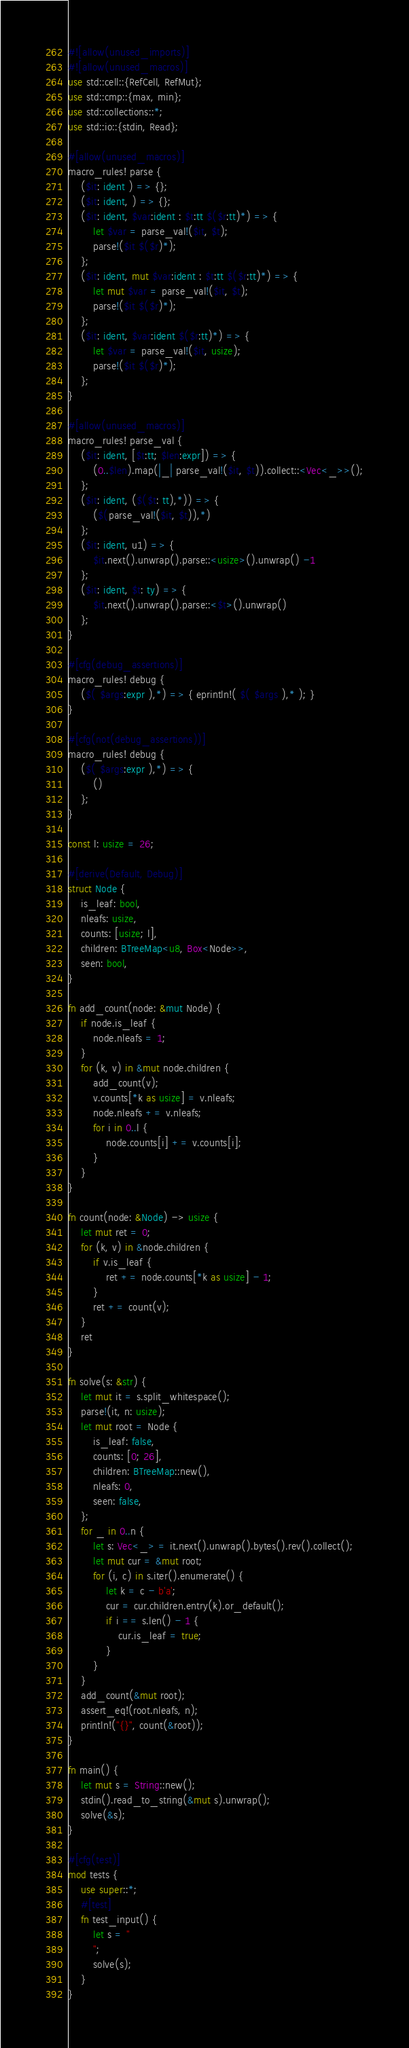<code> <loc_0><loc_0><loc_500><loc_500><_Rust_>#![allow(unused_imports)]
#![allow(unused_macros)]
use std::cell::{RefCell, RefMut};
use std::cmp::{max, min};
use std::collections::*;
use std::io::{stdin, Read};

#[allow(unused_macros)]
macro_rules! parse {
    ($it: ident ) => {};
    ($it: ident, ) => {};
    ($it: ident, $var:ident : $t:tt $($r:tt)*) => {
        let $var = parse_val!($it, $t);
        parse!($it $($r)*);
    };
    ($it: ident, mut $var:ident : $t:tt $($r:tt)*) => {
        let mut $var = parse_val!($it, $t);
        parse!($it $($r)*);
    };
    ($it: ident, $var:ident $($r:tt)*) => {
        let $var = parse_val!($it, usize);
        parse!($it $($r)*);
    };
}

#[allow(unused_macros)]
macro_rules! parse_val {
    ($it: ident, [$t:tt; $len:expr]) => {
        (0..$len).map(|_| parse_val!($it, $t)).collect::<Vec<_>>();
    };
    ($it: ident, ($($t: tt),*)) => {
        ($(parse_val!($it, $t)),*)
    };
    ($it: ident, u1) => {
        $it.next().unwrap().parse::<usize>().unwrap() -1
    };
    ($it: ident, $t: ty) => {
        $it.next().unwrap().parse::<$t>().unwrap()
    };
}

#[cfg(debug_assertions)]
macro_rules! debug {
    ($( $args:expr ),*) => { eprintln!( $( $args ),* ); }
}

#[cfg(not(debug_assertions))]
macro_rules! debug {
    ($( $args:expr ),*) => {
        ()
    };
}

const l: usize = 26;

#[derive(Default, Debug)]
struct Node {
    is_leaf: bool,
    nleafs: usize,
    counts: [usize; l],
    children: BTreeMap<u8, Box<Node>>,
    seen: bool,
}

fn add_count(node: &mut Node) {
    if node.is_leaf {
        node.nleafs = 1;
    }
    for (k, v) in &mut node.children {
        add_count(v);
        v.counts[*k as usize] = v.nleafs;
        node.nleafs += v.nleafs;
        for i in 0..l {
            node.counts[i] += v.counts[i];
        }
    }
}

fn count(node: &Node) -> usize {
    let mut ret = 0;
    for (k, v) in &node.children {
        if v.is_leaf {
            ret += node.counts[*k as usize] - 1;
        }
        ret += count(v);
    }
    ret
}

fn solve(s: &str) {
    let mut it = s.split_whitespace();
    parse!(it, n: usize);
    let mut root = Node {
        is_leaf: false,
        counts: [0; 26],
        children: BTreeMap::new(),
        nleafs: 0,
        seen: false,
    };
    for _ in 0..n {
        let s: Vec<_> = it.next().unwrap().bytes().rev().collect();
        let mut cur = &mut root;
        for (i, c) in s.iter().enumerate() {
            let k = c - b'a';
            cur = cur.children.entry(k).or_default();
            if i == s.len() - 1 {
                cur.is_leaf = true;
            }
        }
    }
    add_count(&mut root);
    assert_eq!(root.nleafs, n);
    println!("{}", count(&root));
}

fn main() {
    let mut s = String::new();
    stdin().read_to_string(&mut s).unwrap();
    solve(&s);
}

#[cfg(test)]
mod tests {
    use super::*;
    #[test]
    fn test_input() {
        let s = "
        ";
        solve(s);
    }
}
</code> 